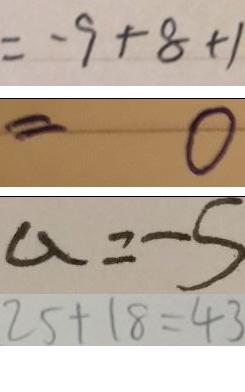<formula> <loc_0><loc_0><loc_500><loc_500>= - 9 + 8 + 1 
 = 0 
 a = - 5 
 2 5 + 1 8 = 4 3</formula> 